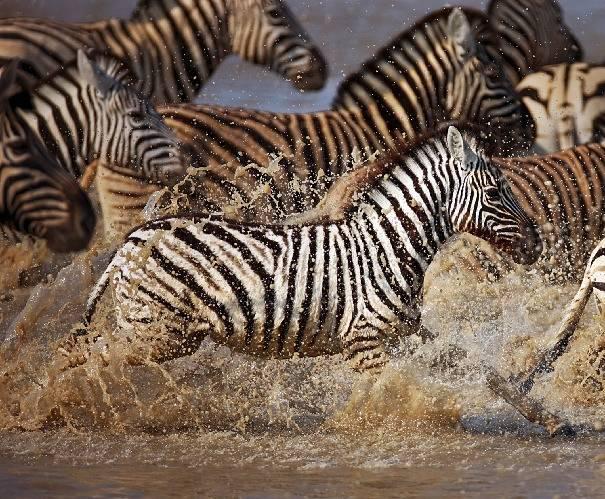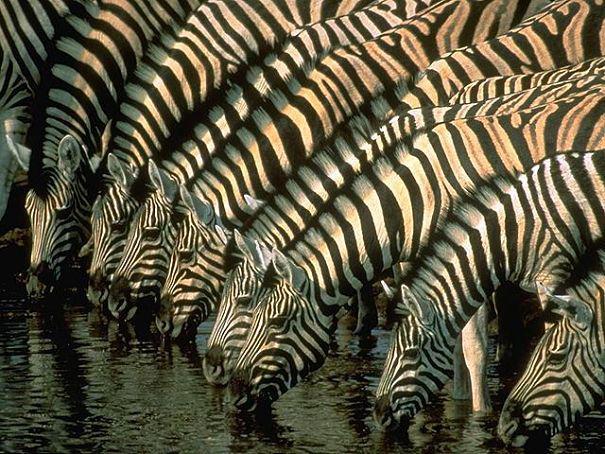The first image is the image on the left, the second image is the image on the right. Assess this claim about the two images: "The left image shows zebras splashing as they run rightward through water, and the image features only zebra-type animals.". Correct or not? Answer yes or no. Yes. The first image is the image on the left, the second image is the image on the right. Assess this claim about the two images: "In at least one image there are three horned elk surrounded by at least 10 zebras.". Correct or not? Answer yes or no. No. 